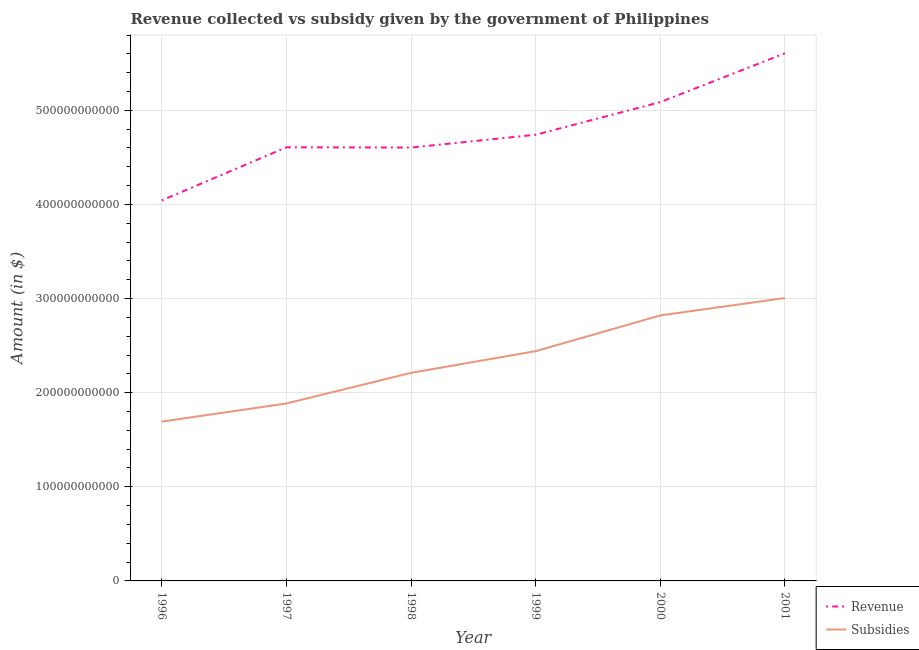How many different coloured lines are there?
Your answer should be very brief. 2. Is the number of lines equal to the number of legend labels?
Offer a very short reply. Yes. What is the amount of revenue collected in 1999?
Give a very brief answer. 4.74e+11. Across all years, what is the maximum amount of revenue collected?
Your response must be concise. 5.61e+11. Across all years, what is the minimum amount of subsidies given?
Make the answer very short. 1.69e+11. In which year was the amount of subsidies given maximum?
Your response must be concise. 2001. In which year was the amount of subsidies given minimum?
Provide a short and direct response. 1996. What is the total amount of revenue collected in the graph?
Keep it short and to the point. 2.87e+12. What is the difference between the amount of revenue collected in 1996 and that in 2001?
Give a very brief answer. -1.56e+11. What is the difference between the amount of revenue collected in 1999 and the amount of subsidies given in 2000?
Ensure brevity in your answer.  1.92e+11. What is the average amount of revenue collected per year?
Make the answer very short. 4.78e+11. In the year 1999, what is the difference between the amount of revenue collected and amount of subsidies given?
Your answer should be compact. 2.30e+11. In how many years, is the amount of revenue collected greater than 500000000000 $?
Make the answer very short. 2. What is the ratio of the amount of subsidies given in 1998 to that in 2000?
Provide a short and direct response. 0.78. Is the amount of subsidies given in 1996 less than that in 2001?
Offer a very short reply. Yes. What is the difference between the highest and the second highest amount of subsidies given?
Provide a succinct answer. 1.85e+1. What is the difference between the highest and the lowest amount of revenue collected?
Offer a terse response. 1.56e+11. Is the amount of revenue collected strictly less than the amount of subsidies given over the years?
Keep it short and to the point. No. How many years are there in the graph?
Give a very brief answer. 6. What is the difference between two consecutive major ticks on the Y-axis?
Keep it short and to the point. 1.00e+11. Are the values on the major ticks of Y-axis written in scientific E-notation?
Offer a terse response. No. Does the graph contain any zero values?
Provide a succinct answer. No. Where does the legend appear in the graph?
Your response must be concise. Bottom right. What is the title of the graph?
Your answer should be compact. Revenue collected vs subsidy given by the government of Philippines. Does "Start a business" appear as one of the legend labels in the graph?
Ensure brevity in your answer.  No. What is the label or title of the Y-axis?
Your answer should be compact. Amount (in $). What is the Amount (in $) in Revenue in 1996?
Provide a short and direct response. 4.04e+11. What is the Amount (in $) in Subsidies in 1996?
Keep it short and to the point. 1.69e+11. What is the Amount (in $) in Revenue in 1997?
Offer a very short reply. 4.61e+11. What is the Amount (in $) of Subsidies in 1997?
Keep it short and to the point. 1.89e+11. What is the Amount (in $) in Revenue in 1998?
Ensure brevity in your answer.  4.60e+11. What is the Amount (in $) of Subsidies in 1998?
Provide a short and direct response. 2.21e+11. What is the Amount (in $) of Revenue in 1999?
Provide a succinct answer. 4.74e+11. What is the Amount (in $) of Subsidies in 1999?
Keep it short and to the point. 2.44e+11. What is the Amount (in $) of Revenue in 2000?
Offer a very short reply. 5.09e+11. What is the Amount (in $) in Subsidies in 2000?
Offer a terse response. 2.82e+11. What is the Amount (in $) in Revenue in 2001?
Your answer should be compact. 5.61e+11. What is the Amount (in $) of Subsidies in 2001?
Your answer should be very brief. 3.01e+11. Across all years, what is the maximum Amount (in $) of Revenue?
Your answer should be compact. 5.61e+11. Across all years, what is the maximum Amount (in $) of Subsidies?
Provide a short and direct response. 3.01e+11. Across all years, what is the minimum Amount (in $) of Revenue?
Your answer should be very brief. 4.04e+11. Across all years, what is the minimum Amount (in $) in Subsidies?
Make the answer very short. 1.69e+11. What is the total Amount (in $) in Revenue in the graph?
Provide a short and direct response. 2.87e+12. What is the total Amount (in $) of Subsidies in the graph?
Make the answer very short. 1.41e+12. What is the difference between the Amount (in $) in Revenue in 1996 and that in 1997?
Keep it short and to the point. -5.65e+1. What is the difference between the Amount (in $) of Subsidies in 1996 and that in 1997?
Your answer should be compact. -1.93e+1. What is the difference between the Amount (in $) in Revenue in 1996 and that in 1998?
Offer a terse response. -5.62e+1. What is the difference between the Amount (in $) of Subsidies in 1996 and that in 1998?
Provide a succinct answer. -5.18e+1. What is the difference between the Amount (in $) of Revenue in 1996 and that in 1999?
Offer a very short reply. -6.98e+1. What is the difference between the Amount (in $) in Subsidies in 1996 and that in 1999?
Offer a terse response. -7.49e+1. What is the difference between the Amount (in $) in Revenue in 1996 and that in 2000?
Make the answer very short. -1.05e+11. What is the difference between the Amount (in $) in Subsidies in 1996 and that in 2000?
Provide a short and direct response. -1.13e+11. What is the difference between the Amount (in $) in Revenue in 1996 and that in 2001?
Offer a very short reply. -1.56e+11. What is the difference between the Amount (in $) of Subsidies in 1996 and that in 2001?
Offer a very short reply. -1.31e+11. What is the difference between the Amount (in $) of Revenue in 1997 and that in 1998?
Provide a succinct answer. 2.75e+08. What is the difference between the Amount (in $) in Subsidies in 1997 and that in 1998?
Make the answer very short. -3.25e+1. What is the difference between the Amount (in $) of Revenue in 1997 and that in 1999?
Provide a succinct answer. -1.34e+1. What is the difference between the Amount (in $) in Subsidies in 1997 and that in 1999?
Your answer should be compact. -5.56e+1. What is the difference between the Amount (in $) of Revenue in 1997 and that in 2000?
Give a very brief answer. -4.81e+1. What is the difference between the Amount (in $) in Subsidies in 1997 and that in 2000?
Keep it short and to the point. -9.36e+1. What is the difference between the Amount (in $) in Revenue in 1997 and that in 2001?
Keep it short and to the point. -9.99e+1. What is the difference between the Amount (in $) of Subsidies in 1997 and that in 2001?
Give a very brief answer. -1.12e+11. What is the difference between the Amount (in $) of Revenue in 1998 and that in 1999?
Your answer should be compact. -1.36e+1. What is the difference between the Amount (in $) in Subsidies in 1998 and that in 1999?
Provide a succinct answer. -2.31e+1. What is the difference between the Amount (in $) in Revenue in 1998 and that in 2000?
Offer a very short reply. -4.83e+1. What is the difference between the Amount (in $) in Subsidies in 1998 and that in 2000?
Make the answer very short. -6.10e+1. What is the difference between the Amount (in $) in Revenue in 1998 and that in 2001?
Your answer should be very brief. -1.00e+11. What is the difference between the Amount (in $) of Subsidies in 1998 and that in 2001?
Offer a terse response. -7.95e+1. What is the difference between the Amount (in $) in Revenue in 1999 and that in 2000?
Provide a short and direct response. -3.47e+1. What is the difference between the Amount (in $) in Subsidies in 1999 and that in 2000?
Your answer should be very brief. -3.80e+1. What is the difference between the Amount (in $) of Revenue in 1999 and that in 2001?
Keep it short and to the point. -8.65e+1. What is the difference between the Amount (in $) in Subsidies in 1999 and that in 2001?
Offer a very short reply. -5.65e+1. What is the difference between the Amount (in $) in Revenue in 2000 and that in 2001?
Provide a succinct answer. -5.18e+1. What is the difference between the Amount (in $) of Subsidies in 2000 and that in 2001?
Provide a short and direct response. -1.85e+1. What is the difference between the Amount (in $) of Revenue in 1996 and the Amount (in $) of Subsidies in 1997?
Make the answer very short. 2.16e+11. What is the difference between the Amount (in $) of Revenue in 1996 and the Amount (in $) of Subsidies in 1998?
Keep it short and to the point. 1.83e+11. What is the difference between the Amount (in $) in Revenue in 1996 and the Amount (in $) in Subsidies in 1999?
Keep it short and to the point. 1.60e+11. What is the difference between the Amount (in $) of Revenue in 1996 and the Amount (in $) of Subsidies in 2000?
Ensure brevity in your answer.  1.22e+11. What is the difference between the Amount (in $) in Revenue in 1996 and the Amount (in $) in Subsidies in 2001?
Provide a succinct answer. 1.04e+11. What is the difference between the Amount (in $) of Revenue in 1997 and the Amount (in $) of Subsidies in 1998?
Provide a succinct answer. 2.40e+11. What is the difference between the Amount (in $) of Revenue in 1997 and the Amount (in $) of Subsidies in 1999?
Keep it short and to the point. 2.17e+11. What is the difference between the Amount (in $) in Revenue in 1997 and the Amount (in $) in Subsidies in 2000?
Offer a terse response. 1.79e+11. What is the difference between the Amount (in $) of Revenue in 1997 and the Amount (in $) of Subsidies in 2001?
Provide a succinct answer. 1.60e+11. What is the difference between the Amount (in $) of Revenue in 1998 and the Amount (in $) of Subsidies in 1999?
Your answer should be very brief. 2.16e+11. What is the difference between the Amount (in $) of Revenue in 1998 and the Amount (in $) of Subsidies in 2000?
Offer a terse response. 1.78e+11. What is the difference between the Amount (in $) in Revenue in 1998 and the Amount (in $) in Subsidies in 2001?
Your answer should be very brief. 1.60e+11. What is the difference between the Amount (in $) in Revenue in 1999 and the Amount (in $) in Subsidies in 2000?
Give a very brief answer. 1.92e+11. What is the difference between the Amount (in $) in Revenue in 1999 and the Amount (in $) in Subsidies in 2001?
Ensure brevity in your answer.  1.73e+11. What is the difference between the Amount (in $) in Revenue in 2000 and the Amount (in $) in Subsidies in 2001?
Your response must be concise. 2.08e+11. What is the average Amount (in $) in Revenue per year?
Keep it short and to the point. 4.78e+11. What is the average Amount (in $) of Subsidies per year?
Keep it short and to the point. 2.34e+11. In the year 1996, what is the difference between the Amount (in $) of Revenue and Amount (in $) of Subsidies?
Give a very brief answer. 2.35e+11. In the year 1997, what is the difference between the Amount (in $) in Revenue and Amount (in $) in Subsidies?
Your answer should be compact. 2.72e+11. In the year 1998, what is the difference between the Amount (in $) of Revenue and Amount (in $) of Subsidies?
Offer a very short reply. 2.39e+11. In the year 1999, what is the difference between the Amount (in $) in Revenue and Amount (in $) in Subsidies?
Provide a short and direct response. 2.30e+11. In the year 2000, what is the difference between the Amount (in $) of Revenue and Amount (in $) of Subsidies?
Offer a terse response. 2.27e+11. In the year 2001, what is the difference between the Amount (in $) in Revenue and Amount (in $) in Subsidies?
Offer a very short reply. 2.60e+11. What is the ratio of the Amount (in $) in Revenue in 1996 to that in 1997?
Your response must be concise. 0.88. What is the ratio of the Amount (in $) of Subsidies in 1996 to that in 1997?
Offer a terse response. 0.9. What is the ratio of the Amount (in $) of Revenue in 1996 to that in 1998?
Your answer should be very brief. 0.88. What is the ratio of the Amount (in $) of Subsidies in 1996 to that in 1998?
Offer a very short reply. 0.77. What is the ratio of the Amount (in $) of Revenue in 1996 to that in 1999?
Your response must be concise. 0.85. What is the ratio of the Amount (in $) of Subsidies in 1996 to that in 1999?
Make the answer very short. 0.69. What is the ratio of the Amount (in $) in Revenue in 1996 to that in 2000?
Make the answer very short. 0.79. What is the ratio of the Amount (in $) of Subsidies in 1996 to that in 2000?
Your answer should be compact. 0.6. What is the ratio of the Amount (in $) of Revenue in 1996 to that in 2001?
Offer a very short reply. 0.72. What is the ratio of the Amount (in $) in Subsidies in 1996 to that in 2001?
Offer a very short reply. 0.56. What is the ratio of the Amount (in $) in Subsidies in 1997 to that in 1998?
Your response must be concise. 0.85. What is the ratio of the Amount (in $) in Revenue in 1997 to that in 1999?
Make the answer very short. 0.97. What is the ratio of the Amount (in $) in Subsidies in 1997 to that in 1999?
Offer a terse response. 0.77. What is the ratio of the Amount (in $) in Revenue in 1997 to that in 2000?
Your answer should be compact. 0.91. What is the ratio of the Amount (in $) of Subsidies in 1997 to that in 2000?
Keep it short and to the point. 0.67. What is the ratio of the Amount (in $) in Revenue in 1997 to that in 2001?
Your response must be concise. 0.82. What is the ratio of the Amount (in $) in Subsidies in 1997 to that in 2001?
Your answer should be compact. 0.63. What is the ratio of the Amount (in $) in Revenue in 1998 to that in 1999?
Your answer should be compact. 0.97. What is the ratio of the Amount (in $) of Subsidies in 1998 to that in 1999?
Your answer should be compact. 0.91. What is the ratio of the Amount (in $) in Revenue in 1998 to that in 2000?
Offer a very short reply. 0.91. What is the ratio of the Amount (in $) of Subsidies in 1998 to that in 2000?
Offer a terse response. 0.78. What is the ratio of the Amount (in $) of Revenue in 1998 to that in 2001?
Ensure brevity in your answer.  0.82. What is the ratio of the Amount (in $) of Subsidies in 1998 to that in 2001?
Offer a very short reply. 0.74. What is the ratio of the Amount (in $) of Revenue in 1999 to that in 2000?
Provide a short and direct response. 0.93. What is the ratio of the Amount (in $) of Subsidies in 1999 to that in 2000?
Ensure brevity in your answer.  0.87. What is the ratio of the Amount (in $) of Revenue in 1999 to that in 2001?
Give a very brief answer. 0.85. What is the ratio of the Amount (in $) in Subsidies in 1999 to that in 2001?
Provide a short and direct response. 0.81. What is the ratio of the Amount (in $) in Revenue in 2000 to that in 2001?
Offer a very short reply. 0.91. What is the ratio of the Amount (in $) in Subsidies in 2000 to that in 2001?
Provide a short and direct response. 0.94. What is the difference between the highest and the second highest Amount (in $) in Revenue?
Offer a very short reply. 5.18e+1. What is the difference between the highest and the second highest Amount (in $) in Subsidies?
Offer a terse response. 1.85e+1. What is the difference between the highest and the lowest Amount (in $) in Revenue?
Your answer should be compact. 1.56e+11. What is the difference between the highest and the lowest Amount (in $) in Subsidies?
Provide a short and direct response. 1.31e+11. 